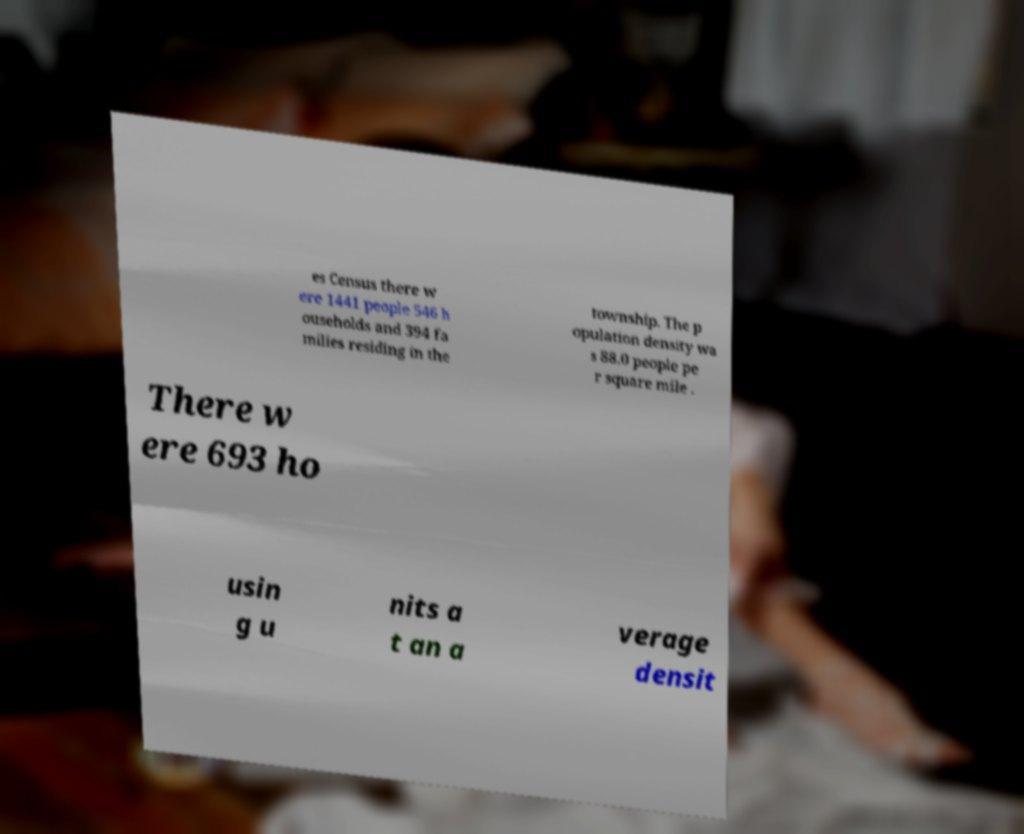Can you read and provide the text displayed in the image?This photo seems to have some interesting text. Can you extract and type it out for me? es Census there w ere 1441 people 546 h ouseholds and 394 fa milies residing in the township. The p opulation density wa s 88.0 people pe r square mile . There w ere 693 ho usin g u nits a t an a verage densit 